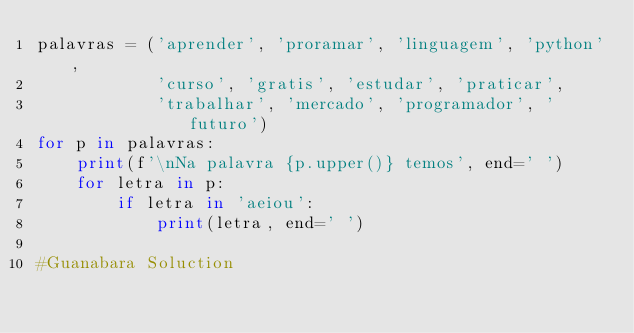<code> <loc_0><loc_0><loc_500><loc_500><_Python_>palavras = ('aprender', 'proramar', 'linguagem', 'python',
            'curso', 'gratis', 'estudar', 'praticar', 
            'trabalhar', 'mercado', 'programador', 'futuro')
for p in palavras:
    print(f'\nNa palavra {p.upper()} temos', end=' ')
    for letra in p:
        if letra in 'aeiou':
            print(letra, end=' ')

#Guanabara Soluction</code> 